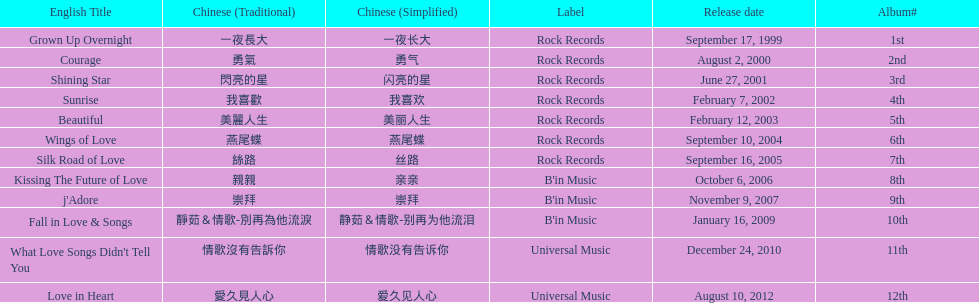What songs were on b'in music or universal music? Kissing The Future of Love, j'Adore, Fall in Love & Songs, What Love Songs Didn't Tell You, Love in Heart. Write the full table. {'header': ['English Title', 'Chinese (Traditional)', 'Chinese (Simplified)', 'Label', 'Release date', 'Album#'], 'rows': [['Grown Up Overnight', '一夜長大', '一夜长大', 'Rock Records', 'September 17, 1999', '1st'], ['Courage', '勇氣', '勇气', 'Rock Records', 'August 2, 2000', '2nd'], ['Shining Star', '閃亮的星', '闪亮的星', 'Rock Records', 'June 27, 2001', '3rd'], ['Sunrise', '我喜歡', '我喜欢', 'Rock Records', 'February 7, 2002', '4th'], ['Beautiful', '美麗人生', '美丽人生', 'Rock Records', 'February 12, 2003', '5th'], ['Wings of Love', '燕尾蝶', '燕尾蝶', 'Rock Records', 'September 10, 2004', '6th'], ['Silk Road of Love', '絲路', '丝路', 'Rock Records', 'September 16, 2005', '7th'], ['Kissing The Future of Love', '親親', '亲亲', "B'in Music", 'October 6, 2006', '8th'], ["j'Adore", '崇拜', '崇拜', "B'in Music", 'November 9, 2007', '9th'], ['Fall in Love & Songs', '靜茹＆情歌-別再為他流淚', '静茹＆情歌-别再为他流泪', "B'in Music", 'January 16, 2009', '10th'], ["What Love Songs Didn't Tell You", '情歌沒有告訴你', '情歌没有告诉你', 'Universal Music', 'December 24, 2010', '11th'], ['Love in Heart', '愛久見人心', '爱久见人心', 'Universal Music', 'August 10, 2012', '12th']]} 